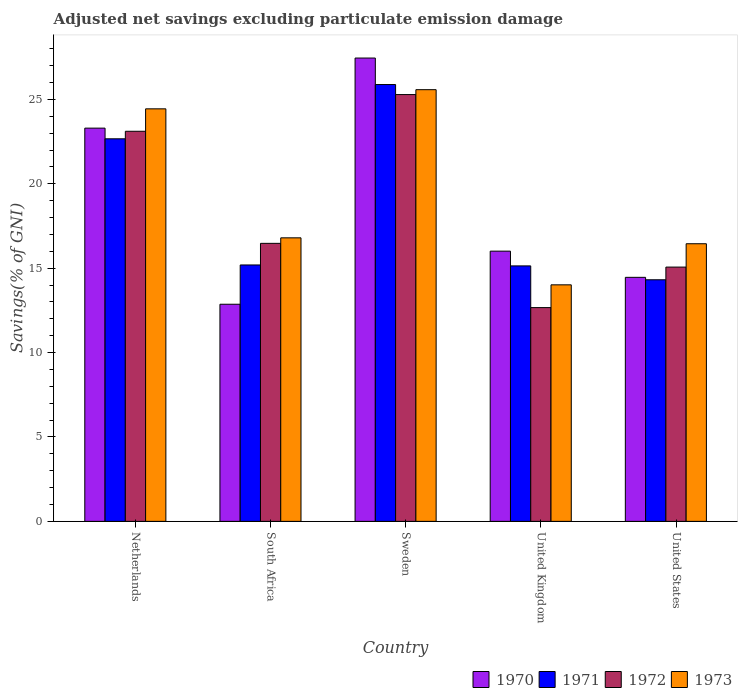How many different coloured bars are there?
Give a very brief answer. 4. Are the number of bars per tick equal to the number of legend labels?
Make the answer very short. Yes. How many bars are there on the 4th tick from the left?
Ensure brevity in your answer.  4. How many bars are there on the 3rd tick from the right?
Offer a very short reply. 4. What is the label of the 2nd group of bars from the left?
Ensure brevity in your answer.  South Africa. What is the adjusted net savings in 1972 in Netherlands?
Give a very brief answer. 23.11. Across all countries, what is the maximum adjusted net savings in 1971?
Ensure brevity in your answer.  25.88. Across all countries, what is the minimum adjusted net savings in 1973?
Offer a very short reply. 14.01. In which country was the adjusted net savings in 1970 maximum?
Provide a succinct answer. Sweden. In which country was the adjusted net savings in 1972 minimum?
Provide a short and direct response. United Kingdom. What is the total adjusted net savings in 1972 in the graph?
Provide a short and direct response. 92.59. What is the difference between the adjusted net savings in 1971 in Netherlands and that in United Kingdom?
Your answer should be very brief. 7.53. What is the difference between the adjusted net savings in 1973 in Sweden and the adjusted net savings in 1972 in United States?
Give a very brief answer. 10.51. What is the average adjusted net savings in 1971 per country?
Offer a very short reply. 18.64. What is the difference between the adjusted net savings of/in 1973 and adjusted net savings of/in 1971 in United Kingdom?
Your response must be concise. -1.12. What is the ratio of the adjusted net savings in 1971 in Netherlands to that in United Kingdom?
Provide a short and direct response. 1.5. Is the adjusted net savings in 1970 in Sweden less than that in United States?
Make the answer very short. No. Is the difference between the adjusted net savings in 1973 in Sweden and United States greater than the difference between the adjusted net savings in 1971 in Sweden and United States?
Give a very brief answer. No. What is the difference between the highest and the second highest adjusted net savings in 1971?
Offer a terse response. 3.21. What is the difference between the highest and the lowest adjusted net savings in 1973?
Provide a succinct answer. 11.56. Is the sum of the adjusted net savings in 1972 in South Africa and United Kingdom greater than the maximum adjusted net savings in 1970 across all countries?
Keep it short and to the point. Yes. Is it the case that in every country, the sum of the adjusted net savings in 1971 and adjusted net savings in 1973 is greater than the sum of adjusted net savings in 1972 and adjusted net savings in 1970?
Provide a short and direct response. No. What does the 4th bar from the left in United Kingdom represents?
Provide a short and direct response. 1973. What does the 2nd bar from the right in Netherlands represents?
Your response must be concise. 1972. Is it the case that in every country, the sum of the adjusted net savings in 1972 and adjusted net savings in 1971 is greater than the adjusted net savings in 1970?
Keep it short and to the point. Yes. Are all the bars in the graph horizontal?
Give a very brief answer. No. How many countries are there in the graph?
Ensure brevity in your answer.  5. Are the values on the major ticks of Y-axis written in scientific E-notation?
Offer a terse response. No. Where does the legend appear in the graph?
Provide a succinct answer. Bottom right. How many legend labels are there?
Provide a succinct answer. 4. What is the title of the graph?
Provide a succinct answer. Adjusted net savings excluding particulate emission damage. Does "1977" appear as one of the legend labels in the graph?
Ensure brevity in your answer.  No. What is the label or title of the X-axis?
Ensure brevity in your answer.  Country. What is the label or title of the Y-axis?
Your answer should be very brief. Savings(% of GNI). What is the Savings(% of GNI) of 1970 in Netherlands?
Keep it short and to the point. 23.3. What is the Savings(% of GNI) in 1971 in Netherlands?
Keep it short and to the point. 22.66. What is the Savings(% of GNI) in 1972 in Netherlands?
Keep it short and to the point. 23.11. What is the Savings(% of GNI) in 1973 in Netherlands?
Ensure brevity in your answer.  24.44. What is the Savings(% of GNI) of 1970 in South Africa?
Offer a terse response. 12.86. What is the Savings(% of GNI) in 1971 in South Africa?
Give a very brief answer. 15.19. What is the Savings(% of GNI) in 1972 in South Africa?
Give a very brief answer. 16.47. What is the Savings(% of GNI) of 1973 in South Africa?
Offer a terse response. 16.8. What is the Savings(% of GNI) of 1970 in Sweden?
Make the answer very short. 27.45. What is the Savings(% of GNI) of 1971 in Sweden?
Offer a terse response. 25.88. What is the Savings(% of GNI) of 1972 in Sweden?
Your response must be concise. 25.28. What is the Savings(% of GNI) of 1973 in Sweden?
Keep it short and to the point. 25.57. What is the Savings(% of GNI) of 1970 in United Kingdom?
Your answer should be very brief. 16.01. What is the Savings(% of GNI) of 1971 in United Kingdom?
Provide a succinct answer. 15.13. What is the Savings(% of GNI) of 1972 in United Kingdom?
Your response must be concise. 12.66. What is the Savings(% of GNI) of 1973 in United Kingdom?
Provide a succinct answer. 14.01. What is the Savings(% of GNI) of 1970 in United States?
Your answer should be very brief. 14.46. What is the Savings(% of GNI) of 1971 in United States?
Offer a very short reply. 14.31. What is the Savings(% of GNI) in 1972 in United States?
Give a very brief answer. 15.06. What is the Savings(% of GNI) in 1973 in United States?
Your response must be concise. 16.45. Across all countries, what is the maximum Savings(% of GNI) of 1970?
Make the answer very short. 27.45. Across all countries, what is the maximum Savings(% of GNI) of 1971?
Make the answer very short. 25.88. Across all countries, what is the maximum Savings(% of GNI) of 1972?
Offer a very short reply. 25.28. Across all countries, what is the maximum Savings(% of GNI) of 1973?
Give a very brief answer. 25.57. Across all countries, what is the minimum Savings(% of GNI) of 1970?
Make the answer very short. 12.86. Across all countries, what is the minimum Savings(% of GNI) of 1971?
Your answer should be compact. 14.31. Across all countries, what is the minimum Savings(% of GNI) in 1972?
Ensure brevity in your answer.  12.66. Across all countries, what is the minimum Savings(% of GNI) in 1973?
Give a very brief answer. 14.01. What is the total Savings(% of GNI) in 1970 in the graph?
Give a very brief answer. 94.07. What is the total Savings(% of GNI) in 1971 in the graph?
Offer a very short reply. 93.18. What is the total Savings(% of GNI) of 1972 in the graph?
Offer a very short reply. 92.59. What is the total Savings(% of GNI) of 1973 in the graph?
Ensure brevity in your answer.  97.27. What is the difference between the Savings(% of GNI) of 1970 in Netherlands and that in South Africa?
Offer a very short reply. 10.43. What is the difference between the Savings(% of GNI) of 1971 in Netherlands and that in South Africa?
Give a very brief answer. 7.47. What is the difference between the Savings(% of GNI) in 1972 in Netherlands and that in South Africa?
Ensure brevity in your answer.  6.64. What is the difference between the Savings(% of GNI) in 1973 in Netherlands and that in South Africa?
Ensure brevity in your answer.  7.64. What is the difference between the Savings(% of GNI) of 1970 in Netherlands and that in Sweden?
Offer a very short reply. -4.15. What is the difference between the Savings(% of GNI) in 1971 in Netherlands and that in Sweden?
Make the answer very short. -3.21. What is the difference between the Savings(% of GNI) of 1972 in Netherlands and that in Sweden?
Offer a terse response. -2.17. What is the difference between the Savings(% of GNI) of 1973 in Netherlands and that in Sweden?
Offer a very short reply. -1.14. What is the difference between the Savings(% of GNI) in 1970 in Netherlands and that in United Kingdom?
Your response must be concise. 7.29. What is the difference between the Savings(% of GNI) in 1971 in Netherlands and that in United Kingdom?
Your answer should be compact. 7.53. What is the difference between the Savings(% of GNI) in 1972 in Netherlands and that in United Kingdom?
Provide a succinct answer. 10.45. What is the difference between the Savings(% of GNI) of 1973 in Netherlands and that in United Kingdom?
Provide a succinct answer. 10.43. What is the difference between the Savings(% of GNI) of 1970 in Netherlands and that in United States?
Ensure brevity in your answer.  8.84. What is the difference between the Savings(% of GNI) of 1971 in Netherlands and that in United States?
Give a very brief answer. 8.35. What is the difference between the Savings(% of GNI) of 1972 in Netherlands and that in United States?
Your response must be concise. 8.05. What is the difference between the Savings(% of GNI) in 1973 in Netherlands and that in United States?
Make the answer very short. 7.99. What is the difference between the Savings(% of GNI) of 1970 in South Africa and that in Sweden?
Provide a succinct answer. -14.59. What is the difference between the Savings(% of GNI) in 1971 in South Africa and that in Sweden?
Provide a short and direct response. -10.69. What is the difference between the Savings(% of GNI) in 1972 in South Africa and that in Sweden?
Offer a very short reply. -8.81. What is the difference between the Savings(% of GNI) in 1973 in South Africa and that in Sweden?
Offer a very short reply. -8.78. What is the difference between the Savings(% of GNI) of 1970 in South Africa and that in United Kingdom?
Your response must be concise. -3.15. What is the difference between the Savings(% of GNI) of 1971 in South Africa and that in United Kingdom?
Provide a short and direct response. 0.06. What is the difference between the Savings(% of GNI) in 1972 in South Africa and that in United Kingdom?
Your answer should be compact. 3.81. What is the difference between the Savings(% of GNI) of 1973 in South Africa and that in United Kingdom?
Your answer should be very brief. 2.78. What is the difference between the Savings(% of GNI) in 1970 in South Africa and that in United States?
Provide a succinct answer. -1.59. What is the difference between the Savings(% of GNI) in 1971 in South Africa and that in United States?
Your response must be concise. 0.88. What is the difference between the Savings(% of GNI) in 1972 in South Africa and that in United States?
Your response must be concise. 1.41. What is the difference between the Savings(% of GNI) of 1973 in South Africa and that in United States?
Provide a succinct answer. 0.35. What is the difference between the Savings(% of GNI) of 1970 in Sweden and that in United Kingdom?
Keep it short and to the point. 11.44. What is the difference between the Savings(% of GNI) of 1971 in Sweden and that in United Kingdom?
Offer a terse response. 10.74. What is the difference between the Savings(% of GNI) in 1972 in Sweden and that in United Kingdom?
Offer a very short reply. 12.62. What is the difference between the Savings(% of GNI) of 1973 in Sweden and that in United Kingdom?
Your answer should be compact. 11.56. What is the difference between the Savings(% of GNI) in 1970 in Sweden and that in United States?
Give a very brief answer. 12.99. What is the difference between the Savings(% of GNI) in 1971 in Sweden and that in United States?
Keep it short and to the point. 11.57. What is the difference between the Savings(% of GNI) in 1972 in Sweden and that in United States?
Ensure brevity in your answer.  10.22. What is the difference between the Savings(% of GNI) of 1973 in Sweden and that in United States?
Offer a terse response. 9.13. What is the difference between the Savings(% of GNI) in 1970 in United Kingdom and that in United States?
Ensure brevity in your answer.  1.55. What is the difference between the Savings(% of GNI) of 1971 in United Kingdom and that in United States?
Make the answer very short. 0.82. What is the difference between the Savings(% of GNI) of 1972 in United Kingdom and that in United States?
Ensure brevity in your answer.  -2.4. What is the difference between the Savings(% of GNI) in 1973 in United Kingdom and that in United States?
Offer a terse response. -2.43. What is the difference between the Savings(% of GNI) of 1970 in Netherlands and the Savings(% of GNI) of 1971 in South Africa?
Provide a succinct answer. 8.11. What is the difference between the Savings(% of GNI) of 1970 in Netherlands and the Savings(% of GNI) of 1972 in South Africa?
Ensure brevity in your answer.  6.83. What is the difference between the Savings(% of GNI) of 1970 in Netherlands and the Savings(% of GNI) of 1973 in South Africa?
Provide a short and direct response. 6.5. What is the difference between the Savings(% of GNI) in 1971 in Netherlands and the Savings(% of GNI) in 1972 in South Africa?
Your answer should be compact. 6.19. What is the difference between the Savings(% of GNI) of 1971 in Netherlands and the Savings(% of GNI) of 1973 in South Africa?
Your answer should be compact. 5.87. What is the difference between the Savings(% of GNI) in 1972 in Netherlands and the Savings(% of GNI) in 1973 in South Africa?
Offer a very short reply. 6.31. What is the difference between the Savings(% of GNI) in 1970 in Netherlands and the Savings(% of GNI) in 1971 in Sweden?
Make the answer very short. -2.58. What is the difference between the Savings(% of GNI) of 1970 in Netherlands and the Savings(% of GNI) of 1972 in Sweden?
Offer a terse response. -1.99. What is the difference between the Savings(% of GNI) of 1970 in Netherlands and the Savings(% of GNI) of 1973 in Sweden?
Provide a short and direct response. -2.28. What is the difference between the Savings(% of GNI) of 1971 in Netherlands and the Savings(% of GNI) of 1972 in Sweden?
Ensure brevity in your answer.  -2.62. What is the difference between the Savings(% of GNI) of 1971 in Netherlands and the Savings(% of GNI) of 1973 in Sweden?
Your answer should be very brief. -2.91. What is the difference between the Savings(% of GNI) in 1972 in Netherlands and the Savings(% of GNI) in 1973 in Sweden?
Provide a short and direct response. -2.46. What is the difference between the Savings(% of GNI) of 1970 in Netherlands and the Savings(% of GNI) of 1971 in United Kingdom?
Provide a short and direct response. 8.16. What is the difference between the Savings(% of GNI) in 1970 in Netherlands and the Savings(% of GNI) in 1972 in United Kingdom?
Provide a short and direct response. 10.63. What is the difference between the Savings(% of GNI) of 1970 in Netherlands and the Savings(% of GNI) of 1973 in United Kingdom?
Your response must be concise. 9.28. What is the difference between the Savings(% of GNI) of 1971 in Netherlands and the Savings(% of GNI) of 1972 in United Kingdom?
Ensure brevity in your answer.  10. What is the difference between the Savings(% of GNI) in 1971 in Netherlands and the Savings(% of GNI) in 1973 in United Kingdom?
Your response must be concise. 8.65. What is the difference between the Savings(% of GNI) in 1972 in Netherlands and the Savings(% of GNI) in 1973 in United Kingdom?
Your answer should be very brief. 9.1. What is the difference between the Savings(% of GNI) of 1970 in Netherlands and the Savings(% of GNI) of 1971 in United States?
Ensure brevity in your answer.  8.98. What is the difference between the Savings(% of GNI) in 1970 in Netherlands and the Savings(% of GNI) in 1972 in United States?
Your response must be concise. 8.23. What is the difference between the Savings(% of GNI) of 1970 in Netherlands and the Savings(% of GNI) of 1973 in United States?
Give a very brief answer. 6.85. What is the difference between the Savings(% of GNI) of 1971 in Netherlands and the Savings(% of GNI) of 1972 in United States?
Keep it short and to the point. 7.6. What is the difference between the Savings(% of GNI) in 1971 in Netherlands and the Savings(% of GNI) in 1973 in United States?
Your response must be concise. 6.22. What is the difference between the Savings(% of GNI) of 1972 in Netherlands and the Savings(% of GNI) of 1973 in United States?
Make the answer very short. 6.66. What is the difference between the Savings(% of GNI) of 1970 in South Africa and the Savings(% of GNI) of 1971 in Sweden?
Your answer should be very brief. -13.02. What is the difference between the Savings(% of GNI) of 1970 in South Africa and the Savings(% of GNI) of 1972 in Sweden?
Your answer should be very brief. -12.42. What is the difference between the Savings(% of GNI) of 1970 in South Africa and the Savings(% of GNI) of 1973 in Sweden?
Your answer should be very brief. -12.71. What is the difference between the Savings(% of GNI) in 1971 in South Africa and the Savings(% of GNI) in 1972 in Sweden?
Your answer should be compact. -10.09. What is the difference between the Savings(% of GNI) in 1971 in South Africa and the Savings(% of GNI) in 1973 in Sweden?
Provide a short and direct response. -10.38. What is the difference between the Savings(% of GNI) of 1972 in South Africa and the Savings(% of GNI) of 1973 in Sweden?
Keep it short and to the point. -9.1. What is the difference between the Savings(% of GNI) of 1970 in South Africa and the Savings(% of GNI) of 1971 in United Kingdom?
Provide a short and direct response. -2.27. What is the difference between the Savings(% of GNI) in 1970 in South Africa and the Savings(% of GNI) in 1972 in United Kingdom?
Your answer should be compact. 0.2. What is the difference between the Savings(% of GNI) of 1970 in South Africa and the Savings(% of GNI) of 1973 in United Kingdom?
Your answer should be very brief. -1.15. What is the difference between the Savings(% of GNI) of 1971 in South Africa and the Savings(% of GNI) of 1972 in United Kingdom?
Your answer should be very brief. 2.53. What is the difference between the Savings(% of GNI) of 1971 in South Africa and the Savings(% of GNI) of 1973 in United Kingdom?
Provide a short and direct response. 1.18. What is the difference between the Savings(% of GNI) of 1972 in South Africa and the Savings(% of GNI) of 1973 in United Kingdom?
Provide a short and direct response. 2.46. What is the difference between the Savings(% of GNI) in 1970 in South Africa and the Savings(% of GNI) in 1971 in United States?
Give a very brief answer. -1.45. What is the difference between the Savings(% of GNI) of 1970 in South Africa and the Savings(% of GNI) of 1972 in United States?
Keep it short and to the point. -2.2. What is the difference between the Savings(% of GNI) of 1970 in South Africa and the Savings(% of GNI) of 1973 in United States?
Your answer should be compact. -3.58. What is the difference between the Savings(% of GNI) in 1971 in South Africa and the Savings(% of GNI) in 1972 in United States?
Provide a succinct answer. 0.13. What is the difference between the Savings(% of GNI) of 1971 in South Africa and the Savings(% of GNI) of 1973 in United States?
Your answer should be compact. -1.26. What is the difference between the Savings(% of GNI) in 1972 in South Africa and the Savings(% of GNI) in 1973 in United States?
Give a very brief answer. 0.02. What is the difference between the Savings(% of GNI) of 1970 in Sweden and the Savings(% of GNI) of 1971 in United Kingdom?
Ensure brevity in your answer.  12.31. What is the difference between the Savings(% of GNI) in 1970 in Sweden and the Savings(% of GNI) in 1972 in United Kingdom?
Provide a succinct answer. 14.78. What is the difference between the Savings(% of GNI) in 1970 in Sweden and the Savings(% of GNI) in 1973 in United Kingdom?
Offer a very short reply. 13.44. What is the difference between the Savings(% of GNI) in 1971 in Sweden and the Savings(% of GNI) in 1972 in United Kingdom?
Keep it short and to the point. 13.21. What is the difference between the Savings(% of GNI) in 1971 in Sweden and the Savings(% of GNI) in 1973 in United Kingdom?
Your response must be concise. 11.87. What is the difference between the Savings(% of GNI) of 1972 in Sweden and the Savings(% of GNI) of 1973 in United Kingdom?
Give a very brief answer. 11.27. What is the difference between the Savings(% of GNI) of 1970 in Sweden and the Savings(% of GNI) of 1971 in United States?
Your answer should be very brief. 13.14. What is the difference between the Savings(% of GNI) of 1970 in Sweden and the Savings(% of GNI) of 1972 in United States?
Offer a very short reply. 12.38. What is the difference between the Savings(% of GNI) of 1970 in Sweden and the Savings(% of GNI) of 1973 in United States?
Your response must be concise. 11. What is the difference between the Savings(% of GNI) in 1971 in Sweden and the Savings(% of GNI) in 1972 in United States?
Ensure brevity in your answer.  10.81. What is the difference between the Savings(% of GNI) in 1971 in Sweden and the Savings(% of GNI) in 1973 in United States?
Make the answer very short. 9.43. What is the difference between the Savings(% of GNI) of 1972 in Sweden and the Savings(% of GNI) of 1973 in United States?
Keep it short and to the point. 8.84. What is the difference between the Savings(% of GNI) in 1970 in United Kingdom and the Savings(% of GNI) in 1971 in United States?
Ensure brevity in your answer.  1.7. What is the difference between the Savings(% of GNI) in 1970 in United Kingdom and the Savings(% of GNI) in 1972 in United States?
Your answer should be very brief. 0.94. What is the difference between the Savings(% of GNI) in 1970 in United Kingdom and the Savings(% of GNI) in 1973 in United States?
Make the answer very short. -0.44. What is the difference between the Savings(% of GNI) of 1971 in United Kingdom and the Savings(% of GNI) of 1972 in United States?
Your answer should be compact. 0.07. What is the difference between the Savings(% of GNI) of 1971 in United Kingdom and the Savings(% of GNI) of 1973 in United States?
Your answer should be compact. -1.31. What is the difference between the Savings(% of GNI) of 1972 in United Kingdom and the Savings(% of GNI) of 1973 in United States?
Provide a succinct answer. -3.78. What is the average Savings(% of GNI) in 1970 per country?
Offer a terse response. 18.81. What is the average Savings(% of GNI) in 1971 per country?
Provide a succinct answer. 18.64. What is the average Savings(% of GNI) in 1972 per country?
Offer a terse response. 18.52. What is the average Savings(% of GNI) of 1973 per country?
Your response must be concise. 19.45. What is the difference between the Savings(% of GNI) of 1970 and Savings(% of GNI) of 1971 in Netherlands?
Ensure brevity in your answer.  0.63. What is the difference between the Savings(% of GNI) in 1970 and Savings(% of GNI) in 1972 in Netherlands?
Your answer should be compact. 0.19. What is the difference between the Savings(% of GNI) of 1970 and Savings(% of GNI) of 1973 in Netherlands?
Provide a short and direct response. -1.14. What is the difference between the Savings(% of GNI) of 1971 and Savings(% of GNI) of 1972 in Netherlands?
Make the answer very short. -0.45. What is the difference between the Savings(% of GNI) in 1971 and Savings(% of GNI) in 1973 in Netherlands?
Your response must be concise. -1.77. What is the difference between the Savings(% of GNI) in 1972 and Savings(% of GNI) in 1973 in Netherlands?
Make the answer very short. -1.33. What is the difference between the Savings(% of GNI) of 1970 and Savings(% of GNI) of 1971 in South Africa?
Your answer should be compact. -2.33. What is the difference between the Savings(% of GNI) of 1970 and Savings(% of GNI) of 1972 in South Africa?
Provide a succinct answer. -3.61. What is the difference between the Savings(% of GNI) in 1970 and Savings(% of GNI) in 1973 in South Africa?
Keep it short and to the point. -3.93. What is the difference between the Savings(% of GNI) of 1971 and Savings(% of GNI) of 1972 in South Africa?
Your answer should be compact. -1.28. What is the difference between the Savings(% of GNI) in 1971 and Savings(% of GNI) in 1973 in South Africa?
Offer a terse response. -1.61. What is the difference between the Savings(% of GNI) of 1972 and Savings(% of GNI) of 1973 in South Africa?
Offer a terse response. -0.33. What is the difference between the Savings(% of GNI) in 1970 and Savings(% of GNI) in 1971 in Sweden?
Give a very brief answer. 1.57. What is the difference between the Savings(% of GNI) in 1970 and Savings(% of GNI) in 1972 in Sweden?
Ensure brevity in your answer.  2.16. What is the difference between the Savings(% of GNI) of 1970 and Savings(% of GNI) of 1973 in Sweden?
Your response must be concise. 1.87. What is the difference between the Savings(% of GNI) in 1971 and Savings(% of GNI) in 1972 in Sweden?
Offer a terse response. 0.59. What is the difference between the Savings(% of GNI) in 1971 and Savings(% of GNI) in 1973 in Sweden?
Your answer should be very brief. 0.3. What is the difference between the Savings(% of GNI) of 1972 and Savings(% of GNI) of 1973 in Sweden?
Keep it short and to the point. -0.29. What is the difference between the Savings(% of GNI) in 1970 and Savings(% of GNI) in 1971 in United Kingdom?
Provide a succinct answer. 0.87. What is the difference between the Savings(% of GNI) in 1970 and Savings(% of GNI) in 1972 in United Kingdom?
Provide a short and direct response. 3.34. What is the difference between the Savings(% of GNI) of 1970 and Savings(% of GNI) of 1973 in United Kingdom?
Give a very brief answer. 2. What is the difference between the Savings(% of GNI) of 1971 and Savings(% of GNI) of 1972 in United Kingdom?
Ensure brevity in your answer.  2.47. What is the difference between the Savings(% of GNI) in 1971 and Savings(% of GNI) in 1973 in United Kingdom?
Provide a succinct answer. 1.12. What is the difference between the Savings(% of GNI) in 1972 and Savings(% of GNI) in 1973 in United Kingdom?
Provide a short and direct response. -1.35. What is the difference between the Savings(% of GNI) of 1970 and Savings(% of GNI) of 1971 in United States?
Your answer should be very brief. 0.14. What is the difference between the Savings(% of GNI) of 1970 and Savings(% of GNI) of 1972 in United States?
Your response must be concise. -0.61. What is the difference between the Savings(% of GNI) of 1970 and Savings(% of GNI) of 1973 in United States?
Make the answer very short. -1.99. What is the difference between the Savings(% of GNI) in 1971 and Savings(% of GNI) in 1972 in United States?
Keep it short and to the point. -0.75. What is the difference between the Savings(% of GNI) of 1971 and Savings(% of GNI) of 1973 in United States?
Offer a terse response. -2.13. What is the difference between the Savings(% of GNI) in 1972 and Savings(% of GNI) in 1973 in United States?
Give a very brief answer. -1.38. What is the ratio of the Savings(% of GNI) of 1970 in Netherlands to that in South Africa?
Provide a succinct answer. 1.81. What is the ratio of the Savings(% of GNI) in 1971 in Netherlands to that in South Africa?
Provide a short and direct response. 1.49. What is the ratio of the Savings(% of GNI) of 1972 in Netherlands to that in South Africa?
Make the answer very short. 1.4. What is the ratio of the Savings(% of GNI) in 1973 in Netherlands to that in South Africa?
Give a very brief answer. 1.46. What is the ratio of the Savings(% of GNI) of 1970 in Netherlands to that in Sweden?
Provide a succinct answer. 0.85. What is the ratio of the Savings(% of GNI) in 1971 in Netherlands to that in Sweden?
Ensure brevity in your answer.  0.88. What is the ratio of the Savings(% of GNI) of 1972 in Netherlands to that in Sweden?
Keep it short and to the point. 0.91. What is the ratio of the Savings(% of GNI) in 1973 in Netherlands to that in Sweden?
Offer a very short reply. 0.96. What is the ratio of the Savings(% of GNI) of 1970 in Netherlands to that in United Kingdom?
Provide a short and direct response. 1.46. What is the ratio of the Savings(% of GNI) of 1971 in Netherlands to that in United Kingdom?
Keep it short and to the point. 1.5. What is the ratio of the Savings(% of GNI) of 1972 in Netherlands to that in United Kingdom?
Offer a terse response. 1.82. What is the ratio of the Savings(% of GNI) of 1973 in Netherlands to that in United Kingdom?
Your response must be concise. 1.74. What is the ratio of the Savings(% of GNI) of 1970 in Netherlands to that in United States?
Ensure brevity in your answer.  1.61. What is the ratio of the Savings(% of GNI) of 1971 in Netherlands to that in United States?
Give a very brief answer. 1.58. What is the ratio of the Savings(% of GNI) of 1972 in Netherlands to that in United States?
Provide a succinct answer. 1.53. What is the ratio of the Savings(% of GNI) of 1973 in Netherlands to that in United States?
Your answer should be very brief. 1.49. What is the ratio of the Savings(% of GNI) of 1970 in South Africa to that in Sweden?
Offer a terse response. 0.47. What is the ratio of the Savings(% of GNI) of 1971 in South Africa to that in Sweden?
Offer a very short reply. 0.59. What is the ratio of the Savings(% of GNI) of 1972 in South Africa to that in Sweden?
Keep it short and to the point. 0.65. What is the ratio of the Savings(% of GNI) in 1973 in South Africa to that in Sweden?
Your answer should be compact. 0.66. What is the ratio of the Savings(% of GNI) of 1970 in South Africa to that in United Kingdom?
Provide a succinct answer. 0.8. What is the ratio of the Savings(% of GNI) in 1971 in South Africa to that in United Kingdom?
Offer a very short reply. 1. What is the ratio of the Savings(% of GNI) of 1972 in South Africa to that in United Kingdom?
Your answer should be compact. 1.3. What is the ratio of the Savings(% of GNI) in 1973 in South Africa to that in United Kingdom?
Provide a succinct answer. 1.2. What is the ratio of the Savings(% of GNI) of 1970 in South Africa to that in United States?
Keep it short and to the point. 0.89. What is the ratio of the Savings(% of GNI) in 1971 in South Africa to that in United States?
Provide a short and direct response. 1.06. What is the ratio of the Savings(% of GNI) in 1972 in South Africa to that in United States?
Provide a short and direct response. 1.09. What is the ratio of the Savings(% of GNI) of 1973 in South Africa to that in United States?
Provide a succinct answer. 1.02. What is the ratio of the Savings(% of GNI) of 1970 in Sweden to that in United Kingdom?
Make the answer very short. 1.71. What is the ratio of the Savings(% of GNI) of 1971 in Sweden to that in United Kingdom?
Provide a short and direct response. 1.71. What is the ratio of the Savings(% of GNI) in 1972 in Sweden to that in United Kingdom?
Offer a very short reply. 2. What is the ratio of the Savings(% of GNI) in 1973 in Sweden to that in United Kingdom?
Your response must be concise. 1.83. What is the ratio of the Savings(% of GNI) in 1970 in Sweden to that in United States?
Make the answer very short. 1.9. What is the ratio of the Savings(% of GNI) of 1971 in Sweden to that in United States?
Provide a succinct answer. 1.81. What is the ratio of the Savings(% of GNI) of 1972 in Sweden to that in United States?
Provide a succinct answer. 1.68. What is the ratio of the Savings(% of GNI) in 1973 in Sweden to that in United States?
Your answer should be compact. 1.55. What is the ratio of the Savings(% of GNI) of 1970 in United Kingdom to that in United States?
Make the answer very short. 1.11. What is the ratio of the Savings(% of GNI) in 1971 in United Kingdom to that in United States?
Make the answer very short. 1.06. What is the ratio of the Savings(% of GNI) of 1972 in United Kingdom to that in United States?
Ensure brevity in your answer.  0.84. What is the ratio of the Savings(% of GNI) in 1973 in United Kingdom to that in United States?
Ensure brevity in your answer.  0.85. What is the difference between the highest and the second highest Savings(% of GNI) in 1970?
Give a very brief answer. 4.15. What is the difference between the highest and the second highest Savings(% of GNI) in 1971?
Ensure brevity in your answer.  3.21. What is the difference between the highest and the second highest Savings(% of GNI) in 1972?
Your answer should be very brief. 2.17. What is the difference between the highest and the second highest Savings(% of GNI) of 1973?
Your answer should be very brief. 1.14. What is the difference between the highest and the lowest Savings(% of GNI) of 1970?
Your answer should be very brief. 14.59. What is the difference between the highest and the lowest Savings(% of GNI) of 1971?
Make the answer very short. 11.57. What is the difference between the highest and the lowest Savings(% of GNI) in 1972?
Make the answer very short. 12.62. What is the difference between the highest and the lowest Savings(% of GNI) in 1973?
Your answer should be compact. 11.56. 